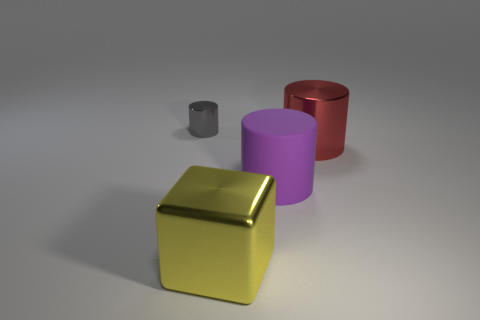Add 1 tiny cyan metal cubes. How many objects exist? 5 Subtract all cylinders. How many objects are left? 1 Subtract 0 red spheres. How many objects are left? 4 Subtract all red cylinders. Subtract all large cylinders. How many objects are left? 1 Add 2 large purple rubber cylinders. How many large purple rubber cylinders are left? 3 Add 4 red blocks. How many red blocks exist? 4 